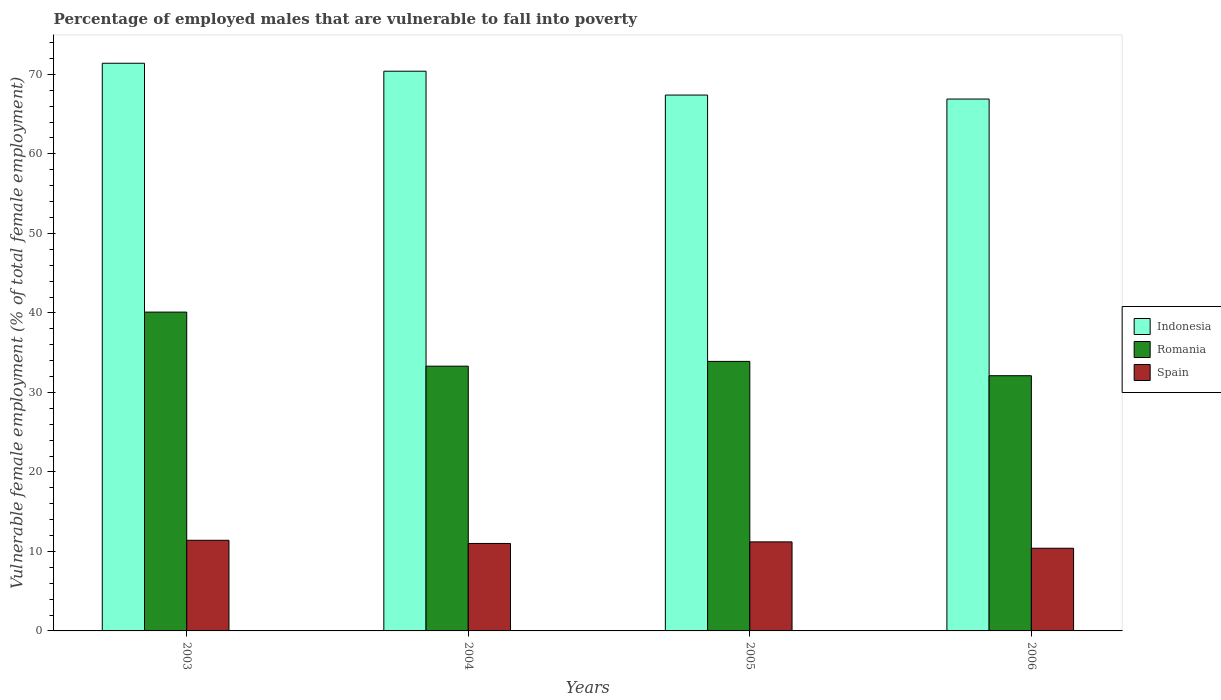How many groups of bars are there?
Ensure brevity in your answer.  4. Are the number of bars on each tick of the X-axis equal?
Give a very brief answer. Yes. What is the label of the 1st group of bars from the left?
Your answer should be compact. 2003. Across all years, what is the maximum percentage of employed males who are vulnerable to fall into poverty in Indonesia?
Keep it short and to the point. 71.4. Across all years, what is the minimum percentage of employed males who are vulnerable to fall into poverty in Indonesia?
Offer a very short reply. 66.9. What is the total percentage of employed males who are vulnerable to fall into poverty in Spain in the graph?
Make the answer very short. 44. What is the difference between the percentage of employed males who are vulnerable to fall into poverty in Romania in 2004 and that in 2005?
Ensure brevity in your answer.  -0.6. What is the difference between the percentage of employed males who are vulnerable to fall into poverty in Spain in 2005 and the percentage of employed males who are vulnerable to fall into poverty in Indonesia in 2003?
Make the answer very short. -60.2. What is the average percentage of employed males who are vulnerable to fall into poverty in Indonesia per year?
Offer a terse response. 69.03. In the year 2006, what is the difference between the percentage of employed males who are vulnerable to fall into poverty in Romania and percentage of employed males who are vulnerable to fall into poverty in Spain?
Provide a short and direct response. 21.7. What is the ratio of the percentage of employed males who are vulnerable to fall into poverty in Romania in 2004 to that in 2006?
Ensure brevity in your answer.  1.04. Is the difference between the percentage of employed males who are vulnerable to fall into poverty in Romania in 2003 and 2005 greater than the difference between the percentage of employed males who are vulnerable to fall into poverty in Spain in 2003 and 2005?
Offer a very short reply. Yes. What is the difference between the highest and the second highest percentage of employed males who are vulnerable to fall into poverty in Indonesia?
Offer a terse response. 1. What is the difference between the highest and the lowest percentage of employed males who are vulnerable to fall into poverty in Indonesia?
Make the answer very short. 4.5. In how many years, is the percentage of employed males who are vulnerable to fall into poverty in Romania greater than the average percentage of employed males who are vulnerable to fall into poverty in Romania taken over all years?
Offer a terse response. 1. Is the sum of the percentage of employed males who are vulnerable to fall into poverty in Indonesia in 2004 and 2005 greater than the maximum percentage of employed males who are vulnerable to fall into poverty in Romania across all years?
Offer a terse response. Yes. What does the 3rd bar from the left in 2004 represents?
Ensure brevity in your answer.  Spain. What does the 1st bar from the right in 2003 represents?
Your response must be concise. Spain. How many bars are there?
Your response must be concise. 12. Are all the bars in the graph horizontal?
Keep it short and to the point. No. How many years are there in the graph?
Provide a short and direct response. 4. Are the values on the major ticks of Y-axis written in scientific E-notation?
Ensure brevity in your answer.  No. Does the graph contain any zero values?
Keep it short and to the point. No. Does the graph contain grids?
Offer a terse response. No. What is the title of the graph?
Your answer should be very brief. Percentage of employed males that are vulnerable to fall into poverty. Does "Romania" appear as one of the legend labels in the graph?
Keep it short and to the point. Yes. What is the label or title of the Y-axis?
Make the answer very short. Vulnerable female employment (% of total female employment). What is the Vulnerable female employment (% of total female employment) in Indonesia in 2003?
Make the answer very short. 71.4. What is the Vulnerable female employment (% of total female employment) of Romania in 2003?
Your answer should be very brief. 40.1. What is the Vulnerable female employment (% of total female employment) of Spain in 2003?
Provide a short and direct response. 11.4. What is the Vulnerable female employment (% of total female employment) of Indonesia in 2004?
Keep it short and to the point. 70.4. What is the Vulnerable female employment (% of total female employment) in Romania in 2004?
Your answer should be very brief. 33.3. What is the Vulnerable female employment (% of total female employment) of Indonesia in 2005?
Your answer should be very brief. 67.4. What is the Vulnerable female employment (% of total female employment) in Romania in 2005?
Ensure brevity in your answer.  33.9. What is the Vulnerable female employment (% of total female employment) in Spain in 2005?
Make the answer very short. 11.2. What is the Vulnerable female employment (% of total female employment) of Indonesia in 2006?
Offer a very short reply. 66.9. What is the Vulnerable female employment (% of total female employment) in Romania in 2006?
Provide a short and direct response. 32.1. What is the Vulnerable female employment (% of total female employment) in Spain in 2006?
Provide a succinct answer. 10.4. Across all years, what is the maximum Vulnerable female employment (% of total female employment) of Indonesia?
Ensure brevity in your answer.  71.4. Across all years, what is the maximum Vulnerable female employment (% of total female employment) in Romania?
Keep it short and to the point. 40.1. Across all years, what is the maximum Vulnerable female employment (% of total female employment) of Spain?
Offer a terse response. 11.4. Across all years, what is the minimum Vulnerable female employment (% of total female employment) in Indonesia?
Keep it short and to the point. 66.9. Across all years, what is the minimum Vulnerable female employment (% of total female employment) in Romania?
Your answer should be very brief. 32.1. Across all years, what is the minimum Vulnerable female employment (% of total female employment) of Spain?
Ensure brevity in your answer.  10.4. What is the total Vulnerable female employment (% of total female employment) of Indonesia in the graph?
Your answer should be very brief. 276.1. What is the total Vulnerable female employment (% of total female employment) of Romania in the graph?
Your response must be concise. 139.4. What is the total Vulnerable female employment (% of total female employment) in Spain in the graph?
Offer a terse response. 44. What is the difference between the Vulnerable female employment (% of total female employment) in Spain in 2003 and that in 2004?
Provide a succinct answer. 0.4. What is the difference between the Vulnerable female employment (% of total female employment) of Romania in 2003 and that in 2006?
Your response must be concise. 8. What is the difference between the Vulnerable female employment (% of total female employment) in Indonesia in 2004 and that in 2005?
Offer a very short reply. 3. What is the difference between the Vulnerable female employment (% of total female employment) of Spain in 2004 and that in 2005?
Your response must be concise. -0.2. What is the difference between the Vulnerable female employment (% of total female employment) in Spain in 2004 and that in 2006?
Give a very brief answer. 0.6. What is the difference between the Vulnerable female employment (% of total female employment) of Indonesia in 2005 and that in 2006?
Make the answer very short. 0.5. What is the difference between the Vulnerable female employment (% of total female employment) in Romania in 2005 and that in 2006?
Offer a very short reply. 1.8. What is the difference between the Vulnerable female employment (% of total female employment) of Indonesia in 2003 and the Vulnerable female employment (% of total female employment) of Romania in 2004?
Your response must be concise. 38.1. What is the difference between the Vulnerable female employment (% of total female employment) of Indonesia in 2003 and the Vulnerable female employment (% of total female employment) of Spain in 2004?
Ensure brevity in your answer.  60.4. What is the difference between the Vulnerable female employment (% of total female employment) of Romania in 2003 and the Vulnerable female employment (% of total female employment) of Spain in 2004?
Provide a succinct answer. 29.1. What is the difference between the Vulnerable female employment (% of total female employment) of Indonesia in 2003 and the Vulnerable female employment (% of total female employment) of Romania in 2005?
Your answer should be very brief. 37.5. What is the difference between the Vulnerable female employment (% of total female employment) in Indonesia in 2003 and the Vulnerable female employment (% of total female employment) in Spain in 2005?
Your response must be concise. 60.2. What is the difference between the Vulnerable female employment (% of total female employment) in Romania in 2003 and the Vulnerable female employment (% of total female employment) in Spain in 2005?
Ensure brevity in your answer.  28.9. What is the difference between the Vulnerable female employment (% of total female employment) of Indonesia in 2003 and the Vulnerable female employment (% of total female employment) of Romania in 2006?
Give a very brief answer. 39.3. What is the difference between the Vulnerable female employment (% of total female employment) of Romania in 2003 and the Vulnerable female employment (% of total female employment) of Spain in 2006?
Ensure brevity in your answer.  29.7. What is the difference between the Vulnerable female employment (% of total female employment) of Indonesia in 2004 and the Vulnerable female employment (% of total female employment) of Romania in 2005?
Ensure brevity in your answer.  36.5. What is the difference between the Vulnerable female employment (% of total female employment) in Indonesia in 2004 and the Vulnerable female employment (% of total female employment) in Spain in 2005?
Offer a very short reply. 59.2. What is the difference between the Vulnerable female employment (% of total female employment) of Romania in 2004 and the Vulnerable female employment (% of total female employment) of Spain in 2005?
Provide a succinct answer. 22.1. What is the difference between the Vulnerable female employment (% of total female employment) in Indonesia in 2004 and the Vulnerable female employment (% of total female employment) in Romania in 2006?
Give a very brief answer. 38.3. What is the difference between the Vulnerable female employment (% of total female employment) in Romania in 2004 and the Vulnerable female employment (% of total female employment) in Spain in 2006?
Make the answer very short. 22.9. What is the difference between the Vulnerable female employment (% of total female employment) of Indonesia in 2005 and the Vulnerable female employment (% of total female employment) of Romania in 2006?
Give a very brief answer. 35.3. What is the difference between the Vulnerable female employment (% of total female employment) of Indonesia in 2005 and the Vulnerable female employment (% of total female employment) of Spain in 2006?
Provide a succinct answer. 57. What is the difference between the Vulnerable female employment (% of total female employment) of Romania in 2005 and the Vulnerable female employment (% of total female employment) of Spain in 2006?
Provide a short and direct response. 23.5. What is the average Vulnerable female employment (% of total female employment) in Indonesia per year?
Provide a short and direct response. 69.03. What is the average Vulnerable female employment (% of total female employment) of Romania per year?
Make the answer very short. 34.85. What is the average Vulnerable female employment (% of total female employment) in Spain per year?
Give a very brief answer. 11. In the year 2003, what is the difference between the Vulnerable female employment (% of total female employment) of Indonesia and Vulnerable female employment (% of total female employment) of Romania?
Make the answer very short. 31.3. In the year 2003, what is the difference between the Vulnerable female employment (% of total female employment) of Indonesia and Vulnerable female employment (% of total female employment) of Spain?
Provide a short and direct response. 60. In the year 2003, what is the difference between the Vulnerable female employment (% of total female employment) in Romania and Vulnerable female employment (% of total female employment) in Spain?
Provide a succinct answer. 28.7. In the year 2004, what is the difference between the Vulnerable female employment (% of total female employment) of Indonesia and Vulnerable female employment (% of total female employment) of Romania?
Your answer should be compact. 37.1. In the year 2004, what is the difference between the Vulnerable female employment (% of total female employment) of Indonesia and Vulnerable female employment (% of total female employment) of Spain?
Give a very brief answer. 59.4. In the year 2004, what is the difference between the Vulnerable female employment (% of total female employment) of Romania and Vulnerable female employment (% of total female employment) of Spain?
Your response must be concise. 22.3. In the year 2005, what is the difference between the Vulnerable female employment (% of total female employment) in Indonesia and Vulnerable female employment (% of total female employment) in Romania?
Offer a terse response. 33.5. In the year 2005, what is the difference between the Vulnerable female employment (% of total female employment) in Indonesia and Vulnerable female employment (% of total female employment) in Spain?
Give a very brief answer. 56.2. In the year 2005, what is the difference between the Vulnerable female employment (% of total female employment) of Romania and Vulnerable female employment (% of total female employment) of Spain?
Ensure brevity in your answer.  22.7. In the year 2006, what is the difference between the Vulnerable female employment (% of total female employment) in Indonesia and Vulnerable female employment (% of total female employment) in Romania?
Your answer should be compact. 34.8. In the year 2006, what is the difference between the Vulnerable female employment (% of total female employment) of Indonesia and Vulnerable female employment (% of total female employment) of Spain?
Ensure brevity in your answer.  56.5. In the year 2006, what is the difference between the Vulnerable female employment (% of total female employment) in Romania and Vulnerable female employment (% of total female employment) in Spain?
Make the answer very short. 21.7. What is the ratio of the Vulnerable female employment (% of total female employment) of Indonesia in 2003 to that in 2004?
Provide a short and direct response. 1.01. What is the ratio of the Vulnerable female employment (% of total female employment) of Romania in 2003 to that in 2004?
Your response must be concise. 1.2. What is the ratio of the Vulnerable female employment (% of total female employment) in Spain in 2003 to that in 2004?
Your response must be concise. 1.04. What is the ratio of the Vulnerable female employment (% of total female employment) in Indonesia in 2003 to that in 2005?
Provide a succinct answer. 1.06. What is the ratio of the Vulnerable female employment (% of total female employment) of Romania in 2003 to that in 2005?
Your response must be concise. 1.18. What is the ratio of the Vulnerable female employment (% of total female employment) of Spain in 2003 to that in 2005?
Your answer should be very brief. 1.02. What is the ratio of the Vulnerable female employment (% of total female employment) of Indonesia in 2003 to that in 2006?
Offer a terse response. 1.07. What is the ratio of the Vulnerable female employment (% of total female employment) in Romania in 2003 to that in 2006?
Your answer should be compact. 1.25. What is the ratio of the Vulnerable female employment (% of total female employment) in Spain in 2003 to that in 2006?
Your answer should be compact. 1.1. What is the ratio of the Vulnerable female employment (% of total female employment) in Indonesia in 2004 to that in 2005?
Offer a terse response. 1.04. What is the ratio of the Vulnerable female employment (% of total female employment) of Romania in 2004 to that in 2005?
Give a very brief answer. 0.98. What is the ratio of the Vulnerable female employment (% of total female employment) in Spain in 2004 to that in 2005?
Make the answer very short. 0.98. What is the ratio of the Vulnerable female employment (% of total female employment) in Indonesia in 2004 to that in 2006?
Give a very brief answer. 1.05. What is the ratio of the Vulnerable female employment (% of total female employment) in Romania in 2004 to that in 2006?
Ensure brevity in your answer.  1.04. What is the ratio of the Vulnerable female employment (% of total female employment) of Spain in 2004 to that in 2006?
Offer a terse response. 1.06. What is the ratio of the Vulnerable female employment (% of total female employment) of Indonesia in 2005 to that in 2006?
Provide a short and direct response. 1.01. What is the ratio of the Vulnerable female employment (% of total female employment) in Romania in 2005 to that in 2006?
Offer a very short reply. 1.06. What is the difference between the highest and the second highest Vulnerable female employment (% of total female employment) in Indonesia?
Offer a terse response. 1. What is the difference between the highest and the second highest Vulnerable female employment (% of total female employment) in Spain?
Your response must be concise. 0.2. What is the difference between the highest and the lowest Vulnerable female employment (% of total female employment) in Indonesia?
Keep it short and to the point. 4.5. What is the difference between the highest and the lowest Vulnerable female employment (% of total female employment) of Spain?
Your response must be concise. 1. 